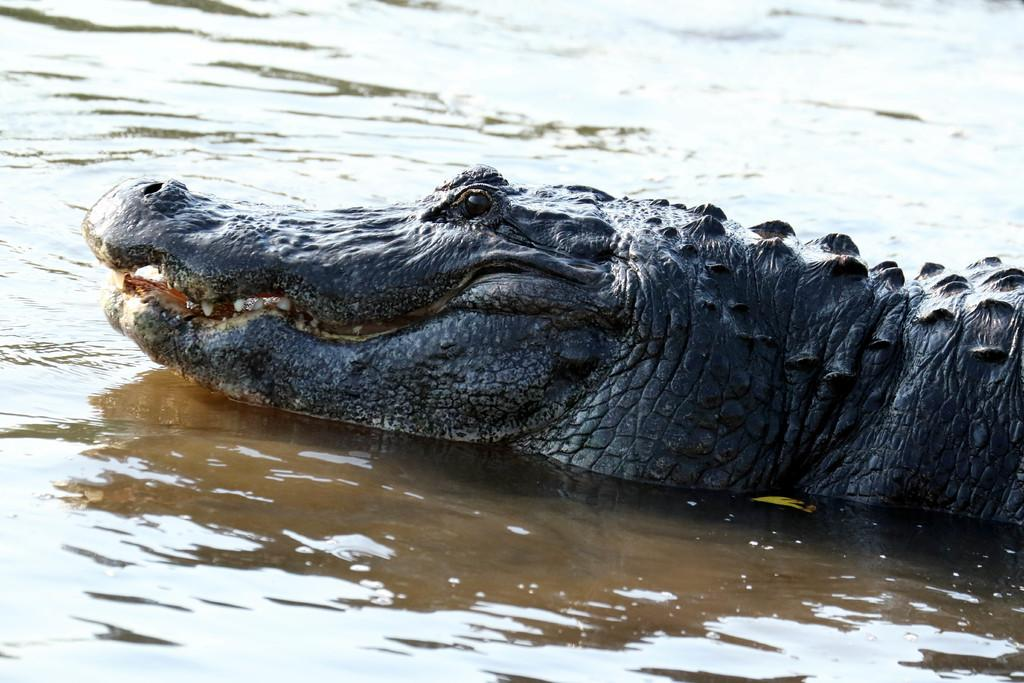What animal is present in the image? There is a crocodile in the image. Where is the crocodile located? The crocodile is in the water. What type of steel is used to make the crocodile's toe in the image? There is no steel or toe present in the image, as it features a crocodile in the water. 